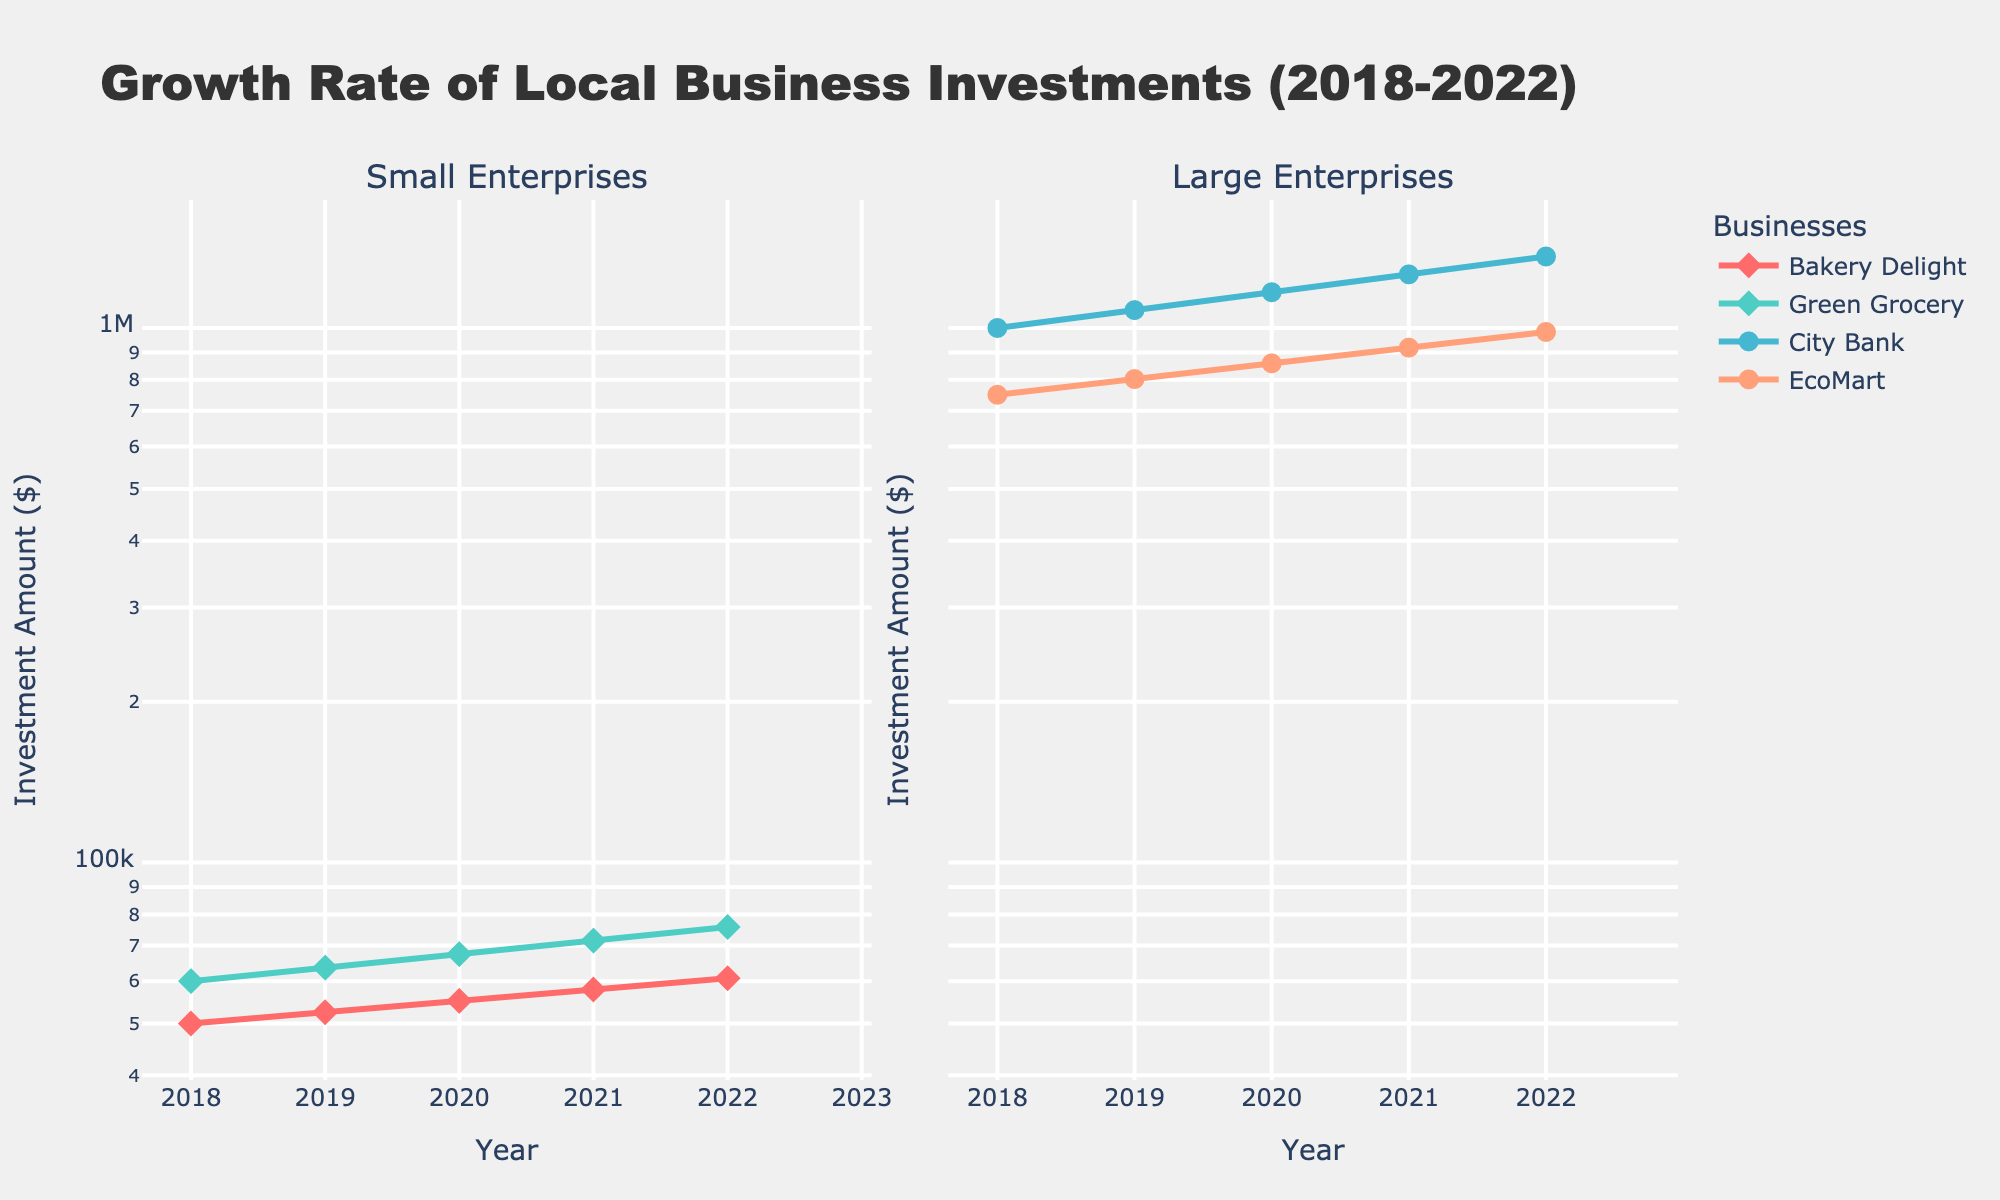How many businesses are being compared in the figure? Count the number of unique business entities on both the left and right subplots. There are 2 on the left (Bakery Delight, Green Grocery) and 2 on the right (City Bank, EcoMart).
Answer: 4 What is the title of the left subplot? The subplot titles can be found at the top of each subplot. The left subplot title is "Small Enterprises."
Answer: Small Enterprises Which large enterprise has the higher investment amount in 2022? Look at the data points at the end of the right subplot (2022). City Bank's investment amount in 2022 is higher ($1,360,488.96) compared to EcoMart ($983,085.81).
Answer: City Bank What is the range of the investment amounts for small enterprises shown in the figure? Identify the lowest and highest investment amounts for small enterprises on the left subplot. The lowest is $50,000 (Bakery Delight in 2018) and the highest is $75,749.47 (Green Grocery in 2022).
Answer: $50,000 to $75,749.47 What is the annual growth rate of Bakery Delight? Check the annotation next to Bakery Delight's data on the left subplot. It is indicated as "Growth: 5%."
Answer: 5% By how much did City Bank's investment amount increase from 2018 to 2022? Look at City Bank's investment amounts in 2018 ($1,000,000) and 2022 ($1,360,488.96). Calculate the increase: $1,360,488.96 - $1,000,000 = $360,488.96.
Answer: $360,488.96 Which small enterprise had a higher investment growth rate over the years? Compare the annotations for small enterprises on the left subplot. Green Grocery has a growth rate of 6%, which is higher than Bakery Delight's 5%.
Answer: Green Grocery Is the investment trend of EcoMart consistently upward from 2018 to 2022? Check EcoMart's data points on the right subplot from 2018 to 2022. The investment amount consistently increases each year.
Answer: Yes What is the total investment amount for all businesses in 2022? Sum the investment amounts of all businesses in 2022. Bakery Delight ($60,775.31), Green Grocery ($75,749.47), City Bank ($1,360,488.96), and EcoMart ($983,085.81). Total = $60,775.31 + $75,749.47 + $1,360,488.96 + $983,085.81 = $2,480,099.55
Answer: $2,480,099.55 Which small enterprise started with the higher investment amount in 2018? Compare Bakery Delight's investment amount in 2018 ($50,000) with Green Grocery's ($60,000). Green Grocery had the higher amount.
Answer: Green Grocery 